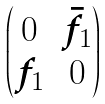<formula> <loc_0><loc_0><loc_500><loc_500>\begin{pmatrix} 0 & \bar { f } _ { 1 } \\ f _ { 1 } & 0 \end{pmatrix}</formula> 